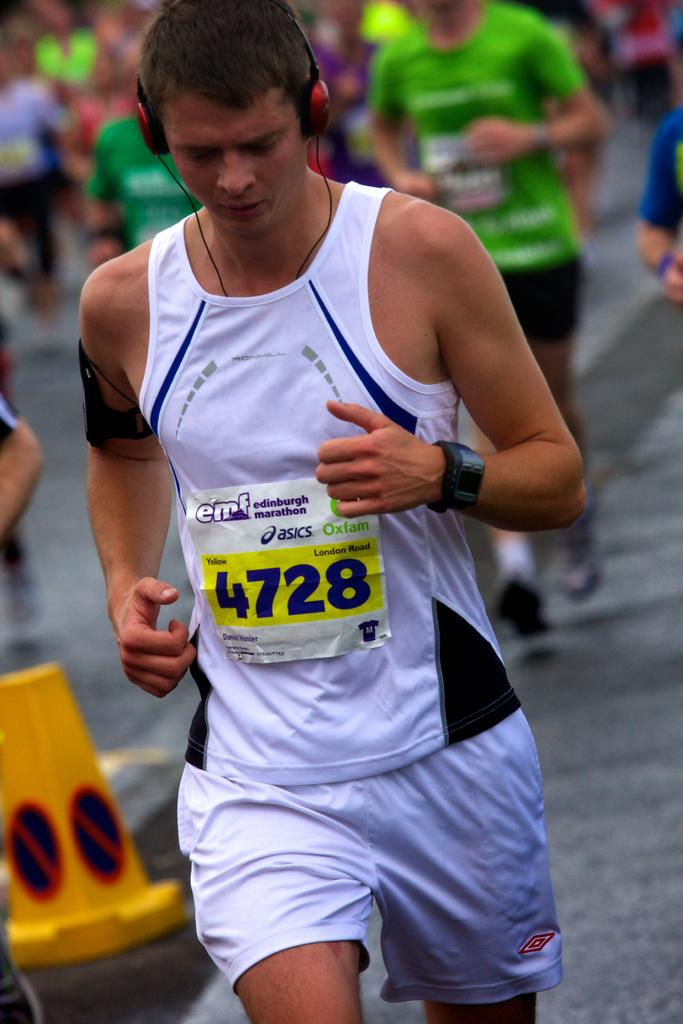<image>
Render a clear and concise summary of the photo. A man running and wearing headphones with 4728 on his shirt. 